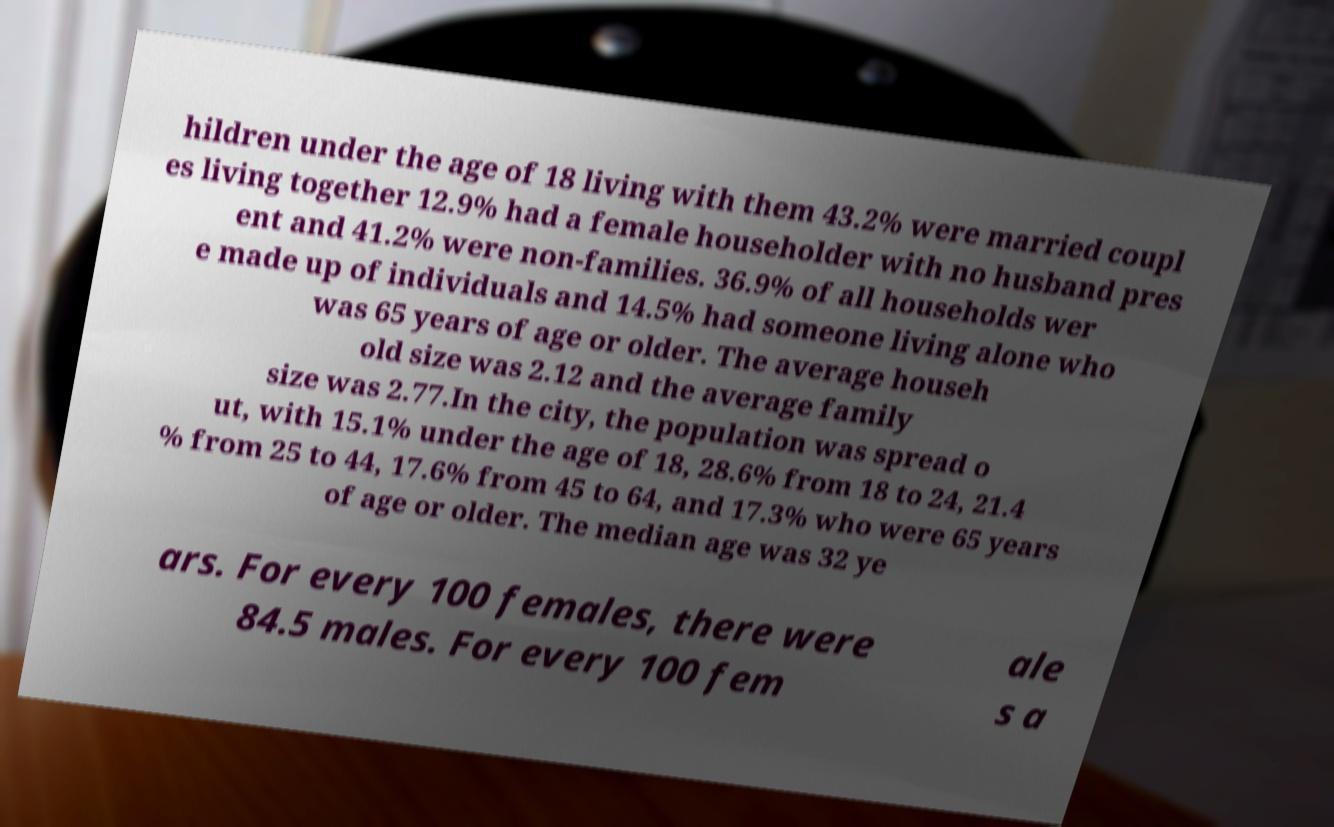Can you accurately transcribe the text from the provided image for me? hildren under the age of 18 living with them 43.2% were married coupl es living together 12.9% had a female householder with no husband pres ent and 41.2% were non-families. 36.9% of all households wer e made up of individuals and 14.5% had someone living alone who was 65 years of age or older. The average househ old size was 2.12 and the average family size was 2.77.In the city, the population was spread o ut, with 15.1% under the age of 18, 28.6% from 18 to 24, 21.4 % from 25 to 44, 17.6% from 45 to 64, and 17.3% who were 65 years of age or older. The median age was 32 ye ars. For every 100 females, there were 84.5 males. For every 100 fem ale s a 